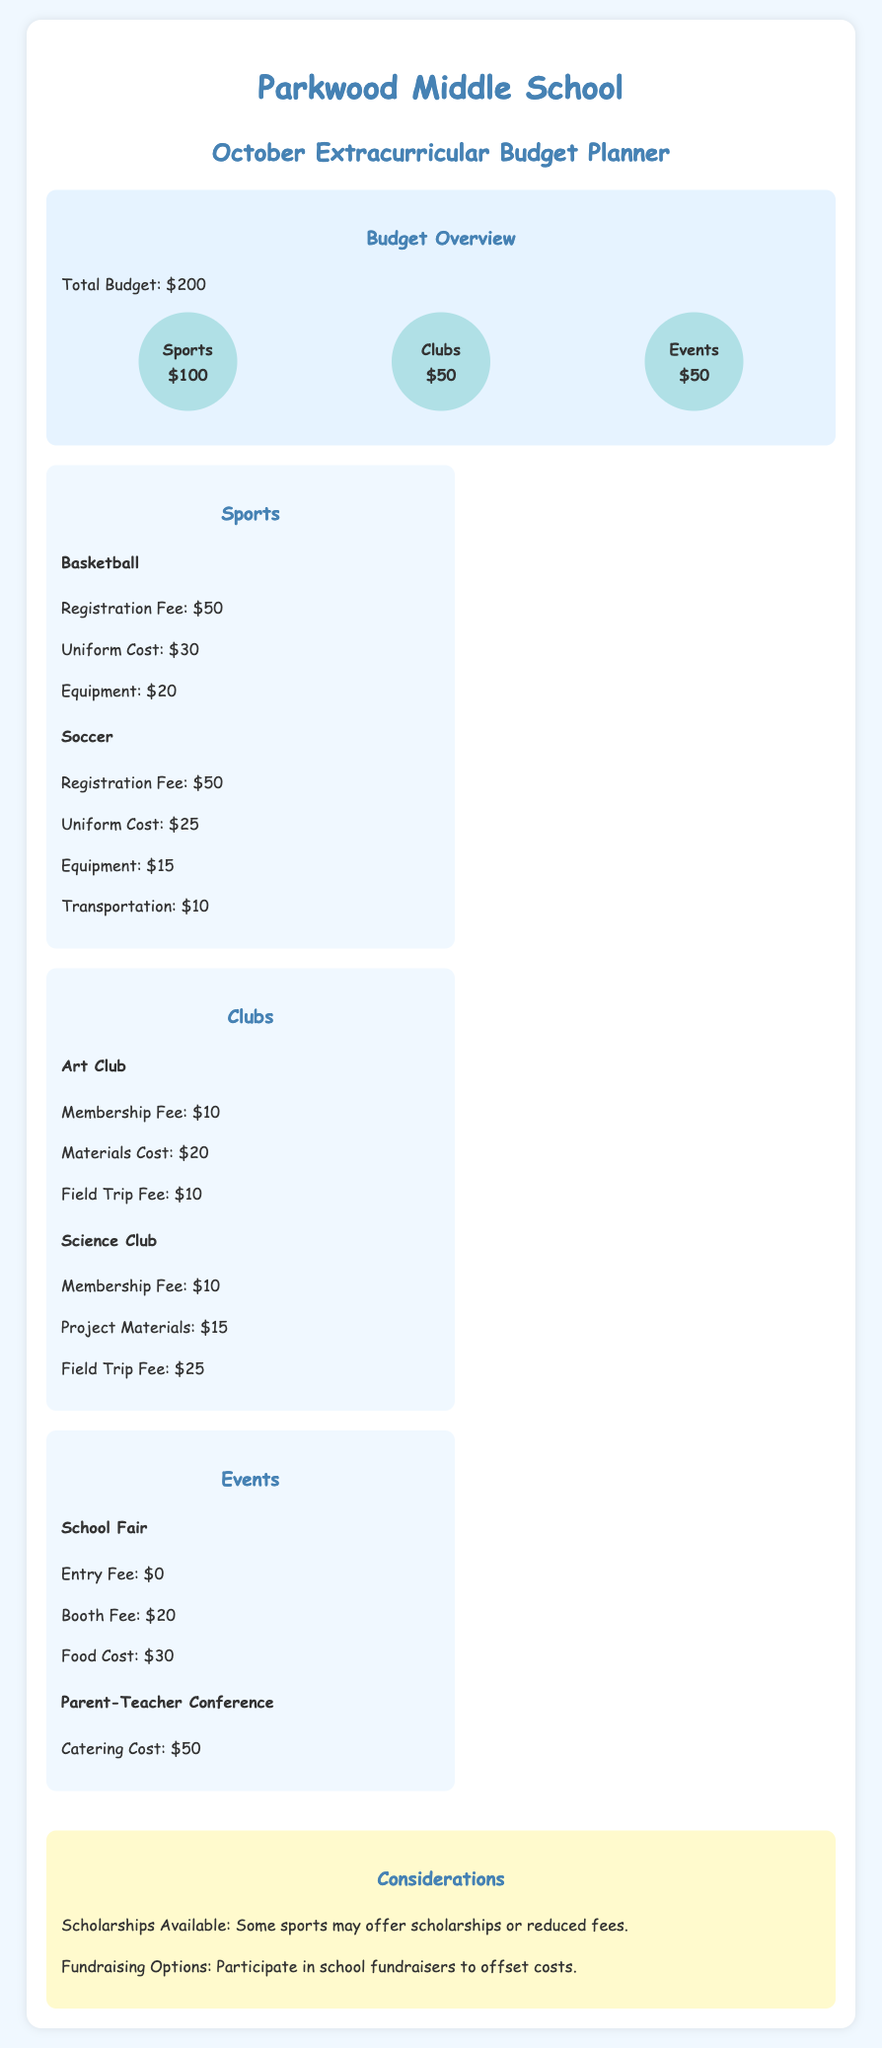What is the total budget for extracurricular activities? The total budget mentioned in the document is provided in the budget overview section.
Answer: $200 How much is allocated for sports? The budget overview section lists the allocation for sports, which can be found directly under the total budget.
Answer: $100 What is the registration fee for soccer? The detailed cost of soccer is specified under the sports section of the document.
Answer: $50 What is the membership fee for the Art Club? The Art Club's associated costs are specified in the clubs section, with the membership fee highlighted.
Answer: $10 How much does a school fair booth cost? The cost for a booth at the school fair is detailed in the events section.
Answer: $20 What is the total cost for participating in basketball? The costs for basketball are summed from the sports section's three detailed items.
Answer: $100 Which club has a higher field trip fee: Science Club or Art Club? The comparison between the field trip fees can be found in the clubs section, directly comparing both clubs.
Answer: Science Club Are there scholarships available for sports? The considerations section addresses financial support options for sports participation.
Answer: Yes What is the total cost of the Parent-Teacher Conference catering? The catering cost is specified in the events section under the Parent-Teacher Conference.
Answer: $50 